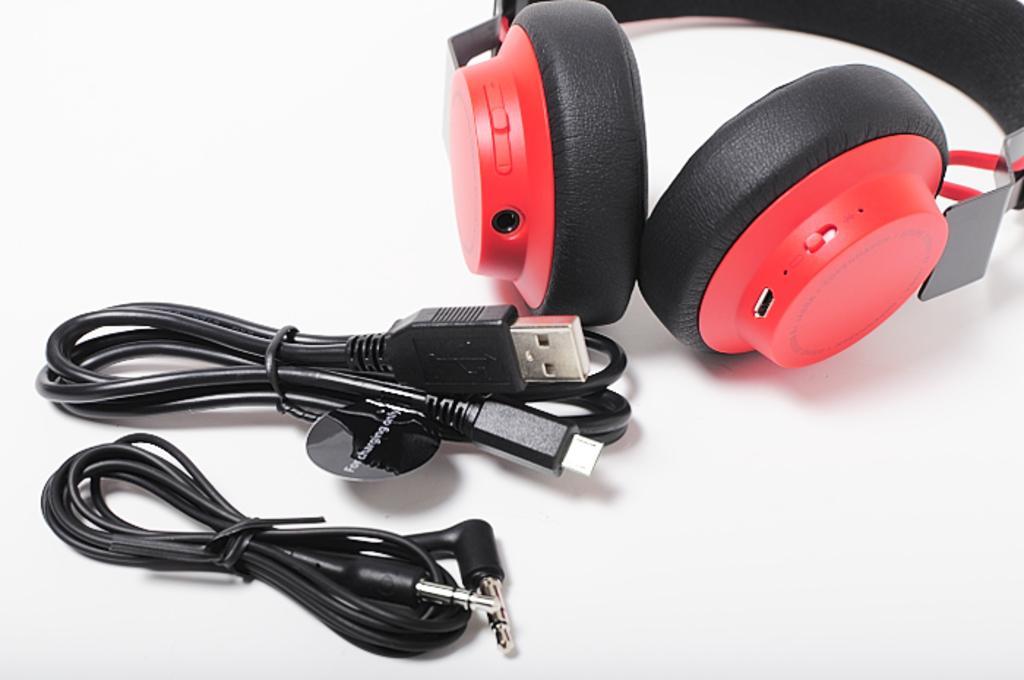Can you describe this image briefly? In this image there are headphones on the table. Beside the head phones there are cables. 